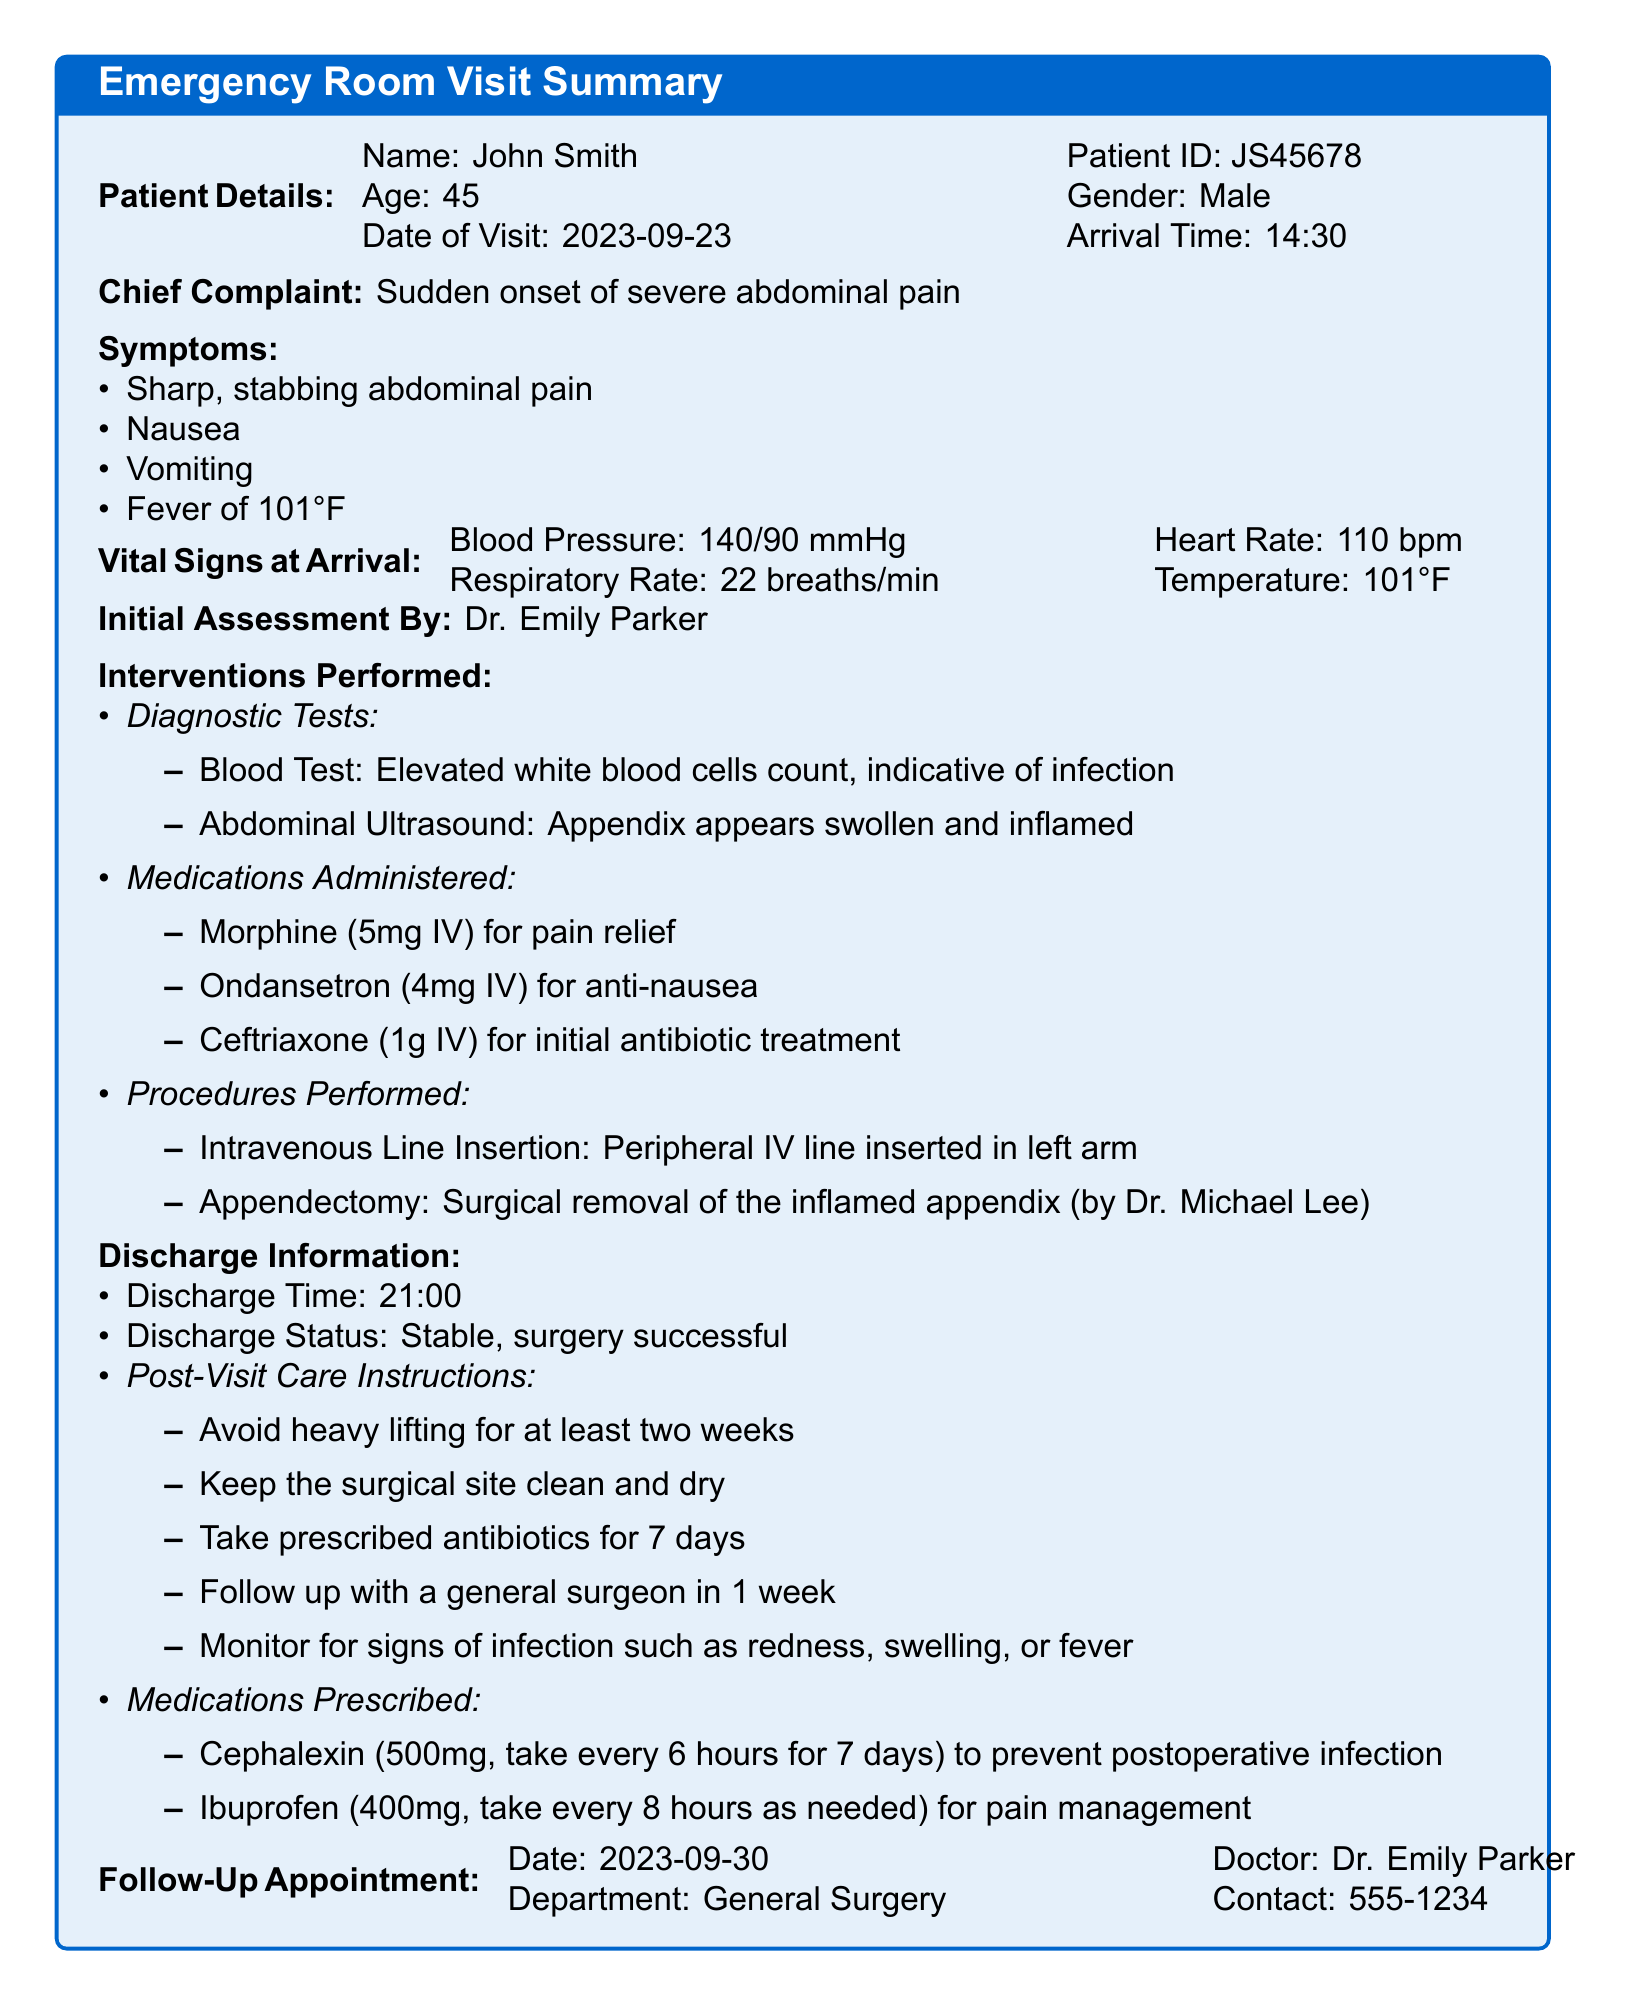What is the name of the patient? The name of the patient is listed at the top of the document under "Patient Details."
Answer: John Smith What was the chief complaint of the patient? The chief complaint is highlighted in the document after the patient details.
Answer: Sudden onset of severe abdominal pain What medications were prescribed upon discharge? The section labeled "Medications Prescribed" provides this information.
Answer: Cephalexin and Ibuprofen When was the patient discharged? The discharge time is specified under "Discharge Information."
Answer: 21:00 Who performed the appendectomy? The name of the doctor who performed the appendectomy is stated under "Procedures Performed."
Answer: Dr. Michael Lee What was the temperature of the patient upon arrival? The patient's temperature is listed in the "Vital Signs at Arrival" section.
Answer: 101°F What follow-up appointment date was scheduled? The follow-up appointment date is noted in the "Follow-Up Appointment" section.
Answer: 2023-09-30 What is one of the post-visit care instructions? The post-visit care instructions are listed under "Post-Visit Care Instructions."
Answer: Avoid heavy lifting for at least two weeks What was indicated by the blood test? The indication from the blood test can be found in the "Interventions Performed" section under diagnostic tests.
Answer: Elevated white blood cells count, indicative of infection 